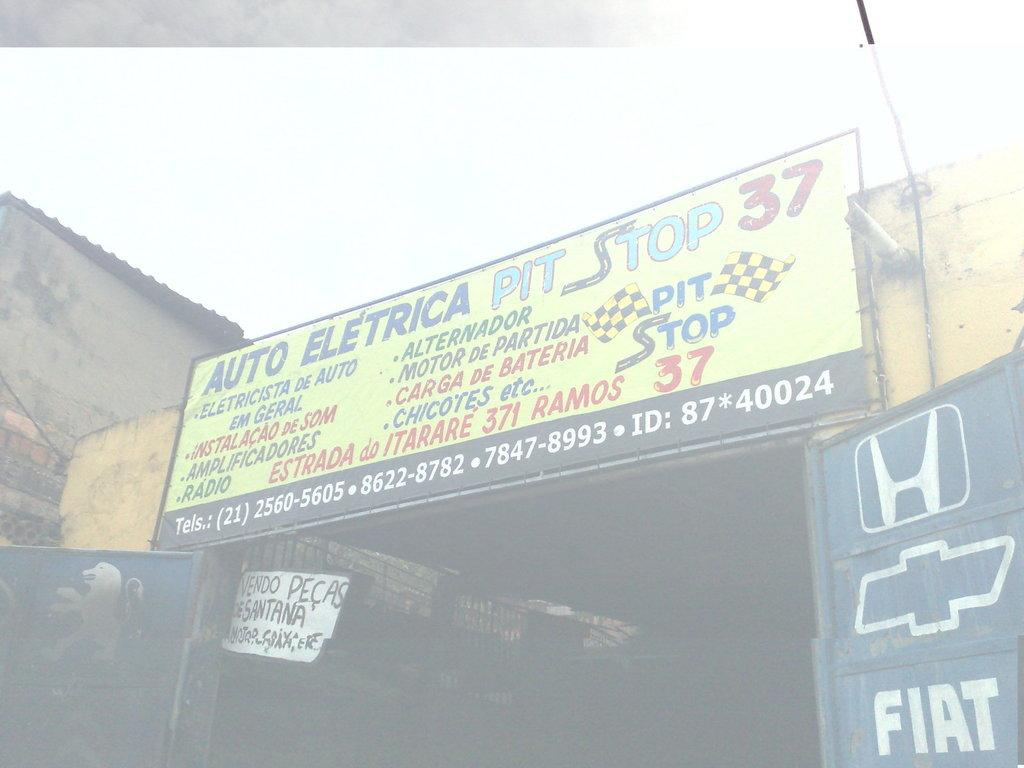<image>
Summarize the visual content of the image. A sign for Auto Electrica Pit Stop 37 sits above a walkway. 